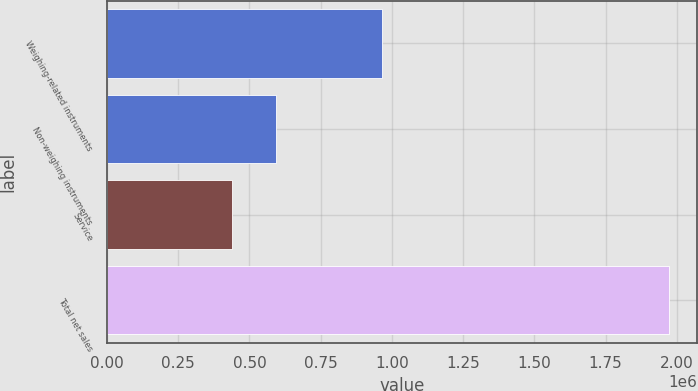Convert chart. <chart><loc_0><loc_0><loc_500><loc_500><bar_chart><fcel>Weighing-related instruments<fcel>Non-weighing instruments<fcel>Service<fcel>Total net sales<nl><fcel>965454<fcel>593803<fcel>440521<fcel>1.97334e+06<nl></chart> 